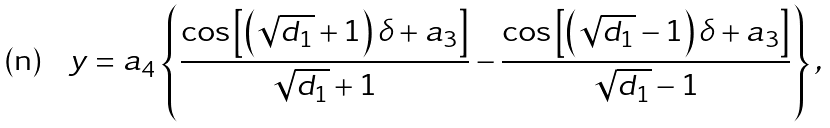Convert formula to latex. <formula><loc_0><loc_0><loc_500><loc_500>y = a _ { 4 } \left \{ \frac { \cos \left [ \left ( \sqrt { d _ { 1 } } + 1 \right ) \delta + a _ { 3 } \right ] } { \sqrt { d _ { 1 } } + 1 } - \frac { \cos \left [ \left ( \sqrt { d _ { 1 } } - 1 \right ) \delta + a _ { 3 } \right ] } { \sqrt { d _ { 1 } } - 1 } \right \} ,</formula> 